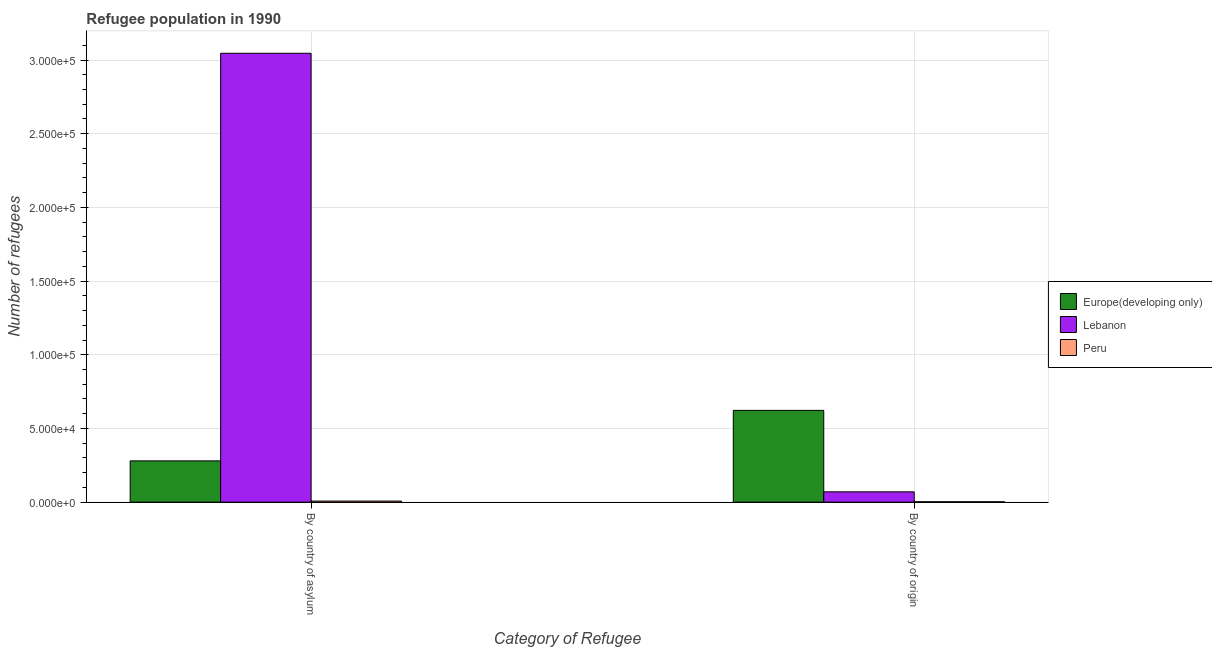How many different coloured bars are there?
Your answer should be compact. 3. How many bars are there on the 2nd tick from the left?
Your answer should be compact. 3. What is the label of the 1st group of bars from the left?
Make the answer very short. By country of asylum. What is the number of refugees by country of asylum in Europe(developing only)?
Your answer should be very brief. 2.80e+04. Across all countries, what is the maximum number of refugees by country of asylum?
Provide a succinct answer. 3.05e+05. Across all countries, what is the minimum number of refugees by country of origin?
Provide a succinct answer. 256. In which country was the number of refugees by country of asylum maximum?
Provide a succinct answer. Lebanon. What is the total number of refugees by country of asylum in the graph?
Ensure brevity in your answer.  3.33e+05. What is the difference between the number of refugees by country of origin in Peru and that in Europe(developing only)?
Provide a succinct answer. -6.20e+04. What is the difference between the number of refugees by country of origin in Europe(developing only) and the number of refugees by country of asylum in Lebanon?
Keep it short and to the point. -2.42e+05. What is the average number of refugees by country of asylum per country?
Make the answer very short. 1.11e+05. What is the difference between the number of refugees by country of origin and number of refugees by country of asylum in Lebanon?
Your answer should be very brief. -2.98e+05. In how many countries, is the number of refugees by country of origin greater than 120000 ?
Provide a succinct answer. 0. What is the ratio of the number of refugees by country of origin in Lebanon to that in Europe(developing only)?
Keep it short and to the point. 0.11. Is the number of refugees by country of asylum in Europe(developing only) less than that in Lebanon?
Keep it short and to the point. Yes. What does the 3rd bar from the right in By country of origin represents?
Make the answer very short. Europe(developing only). Are all the bars in the graph horizontal?
Your response must be concise. No. How many countries are there in the graph?
Offer a terse response. 3. What is the difference between two consecutive major ticks on the Y-axis?
Provide a short and direct response. 5.00e+04. Are the values on the major ticks of Y-axis written in scientific E-notation?
Your response must be concise. Yes. Does the graph contain any zero values?
Keep it short and to the point. No. How are the legend labels stacked?
Ensure brevity in your answer.  Vertical. What is the title of the graph?
Provide a short and direct response. Refugee population in 1990. Does "Jordan" appear as one of the legend labels in the graph?
Offer a very short reply. No. What is the label or title of the X-axis?
Make the answer very short. Category of Refugee. What is the label or title of the Y-axis?
Ensure brevity in your answer.  Number of refugees. What is the Number of refugees of Europe(developing only) in By country of asylum?
Ensure brevity in your answer.  2.80e+04. What is the Number of refugees of Lebanon in By country of asylum?
Give a very brief answer. 3.05e+05. What is the Number of refugees of Peru in By country of asylum?
Give a very brief answer. 724. What is the Number of refugees of Europe(developing only) in By country of origin?
Your response must be concise. 6.23e+04. What is the Number of refugees in Lebanon in By country of origin?
Make the answer very short. 6993. What is the Number of refugees in Peru in By country of origin?
Offer a very short reply. 256. Across all Category of Refugee, what is the maximum Number of refugees in Europe(developing only)?
Provide a succinct answer. 6.23e+04. Across all Category of Refugee, what is the maximum Number of refugees of Lebanon?
Offer a very short reply. 3.05e+05. Across all Category of Refugee, what is the maximum Number of refugees in Peru?
Provide a short and direct response. 724. Across all Category of Refugee, what is the minimum Number of refugees of Europe(developing only)?
Keep it short and to the point. 2.80e+04. Across all Category of Refugee, what is the minimum Number of refugees of Lebanon?
Give a very brief answer. 6993. Across all Category of Refugee, what is the minimum Number of refugees in Peru?
Provide a succinct answer. 256. What is the total Number of refugees of Europe(developing only) in the graph?
Offer a very short reply. 9.03e+04. What is the total Number of refugees of Lebanon in the graph?
Give a very brief answer. 3.12e+05. What is the total Number of refugees of Peru in the graph?
Ensure brevity in your answer.  980. What is the difference between the Number of refugees of Europe(developing only) in By country of asylum and that in By country of origin?
Your response must be concise. -3.43e+04. What is the difference between the Number of refugees of Lebanon in By country of asylum and that in By country of origin?
Make the answer very short. 2.98e+05. What is the difference between the Number of refugees in Peru in By country of asylum and that in By country of origin?
Your answer should be very brief. 468. What is the difference between the Number of refugees of Europe(developing only) in By country of asylum and the Number of refugees of Lebanon in By country of origin?
Offer a very short reply. 2.10e+04. What is the difference between the Number of refugees of Europe(developing only) in By country of asylum and the Number of refugees of Peru in By country of origin?
Give a very brief answer. 2.77e+04. What is the difference between the Number of refugees of Lebanon in By country of asylum and the Number of refugees of Peru in By country of origin?
Make the answer very short. 3.04e+05. What is the average Number of refugees of Europe(developing only) per Category of Refugee?
Your answer should be very brief. 4.51e+04. What is the average Number of refugees in Lebanon per Category of Refugee?
Provide a succinct answer. 1.56e+05. What is the average Number of refugees of Peru per Category of Refugee?
Provide a short and direct response. 490. What is the difference between the Number of refugees of Europe(developing only) and Number of refugees of Lebanon in By country of asylum?
Give a very brief answer. -2.77e+05. What is the difference between the Number of refugees of Europe(developing only) and Number of refugees of Peru in By country of asylum?
Provide a succinct answer. 2.73e+04. What is the difference between the Number of refugees in Lebanon and Number of refugees in Peru in By country of asylum?
Keep it short and to the point. 3.04e+05. What is the difference between the Number of refugees of Europe(developing only) and Number of refugees of Lebanon in By country of origin?
Ensure brevity in your answer.  5.53e+04. What is the difference between the Number of refugees of Europe(developing only) and Number of refugees of Peru in By country of origin?
Provide a short and direct response. 6.20e+04. What is the difference between the Number of refugees of Lebanon and Number of refugees of Peru in By country of origin?
Provide a short and direct response. 6737. What is the ratio of the Number of refugees in Europe(developing only) in By country of asylum to that in By country of origin?
Make the answer very short. 0.45. What is the ratio of the Number of refugees in Lebanon in By country of asylum to that in By country of origin?
Provide a succinct answer. 43.56. What is the ratio of the Number of refugees of Peru in By country of asylum to that in By country of origin?
Give a very brief answer. 2.83. What is the difference between the highest and the second highest Number of refugees in Europe(developing only)?
Offer a terse response. 3.43e+04. What is the difference between the highest and the second highest Number of refugees of Lebanon?
Give a very brief answer. 2.98e+05. What is the difference between the highest and the second highest Number of refugees in Peru?
Your answer should be very brief. 468. What is the difference between the highest and the lowest Number of refugees in Europe(developing only)?
Provide a succinct answer. 3.43e+04. What is the difference between the highest and the lowest Number of refugees in Lebanon?
Give a very brief answer. 2.98e+05. What is the difference between the highest and the lowest Number of refugees of Peru?
Make the answer very short. 468. 